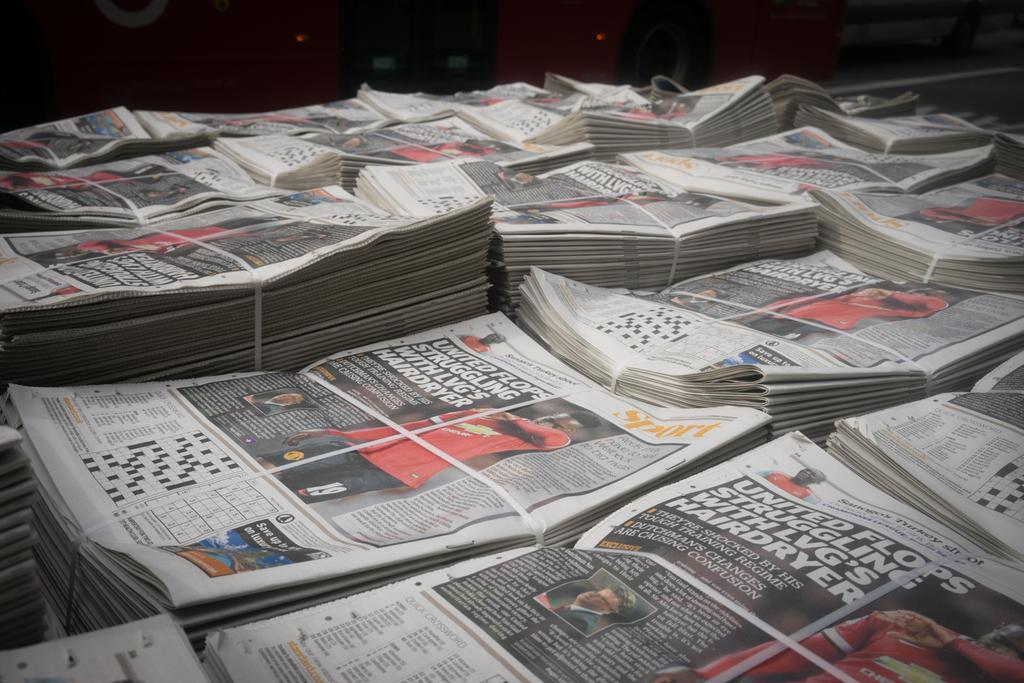<image>
Share a concise interpretation of the image provided. Many issues of Sport newspaper are bundled and stacked. 